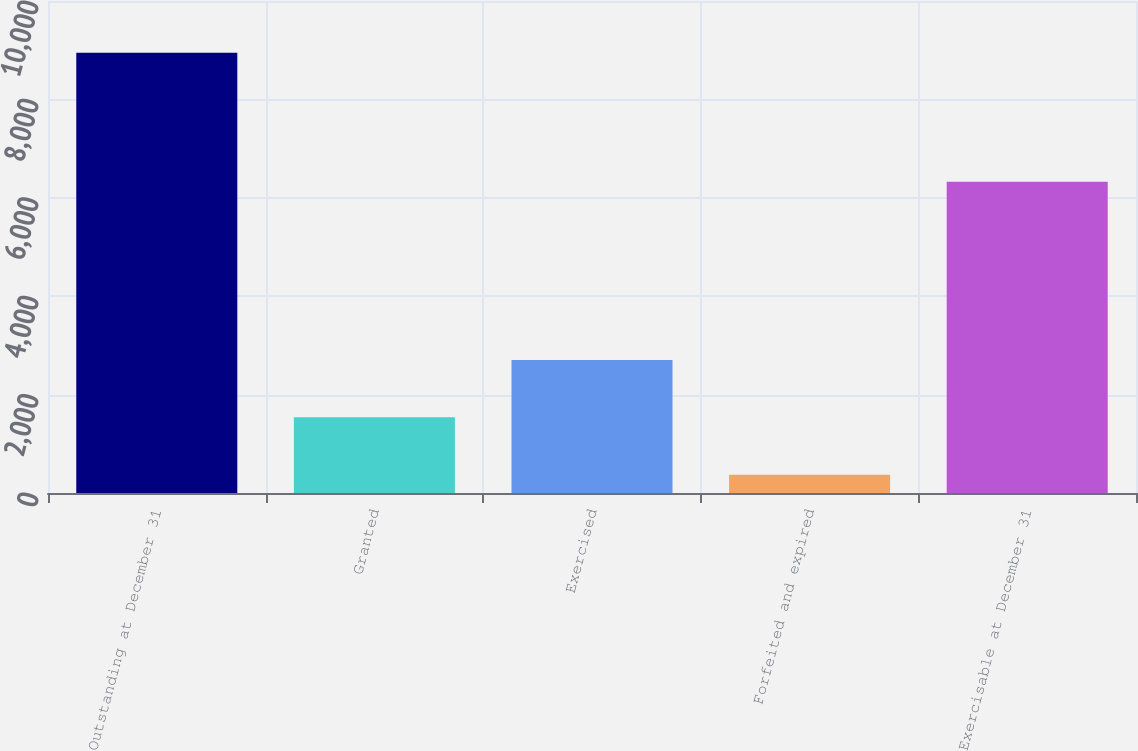Convert chart to OTSL. <chart><loc_0><loc_0><loc_500><loc_500><bar_chart><fcel>Outstanding at December 31<fcel>Granted<fcel>Exercised<fcel>Forfeited and expired<fcel>Exercisable at December 31<nl><fcel>8946<fcel>1537.3<fcel>2703.6<fcel>371<fcel>6327<nl></chart> 